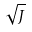<formula> <loc_0><loc_0><loc_500><loc_500>\sqrt { J }</formula> 